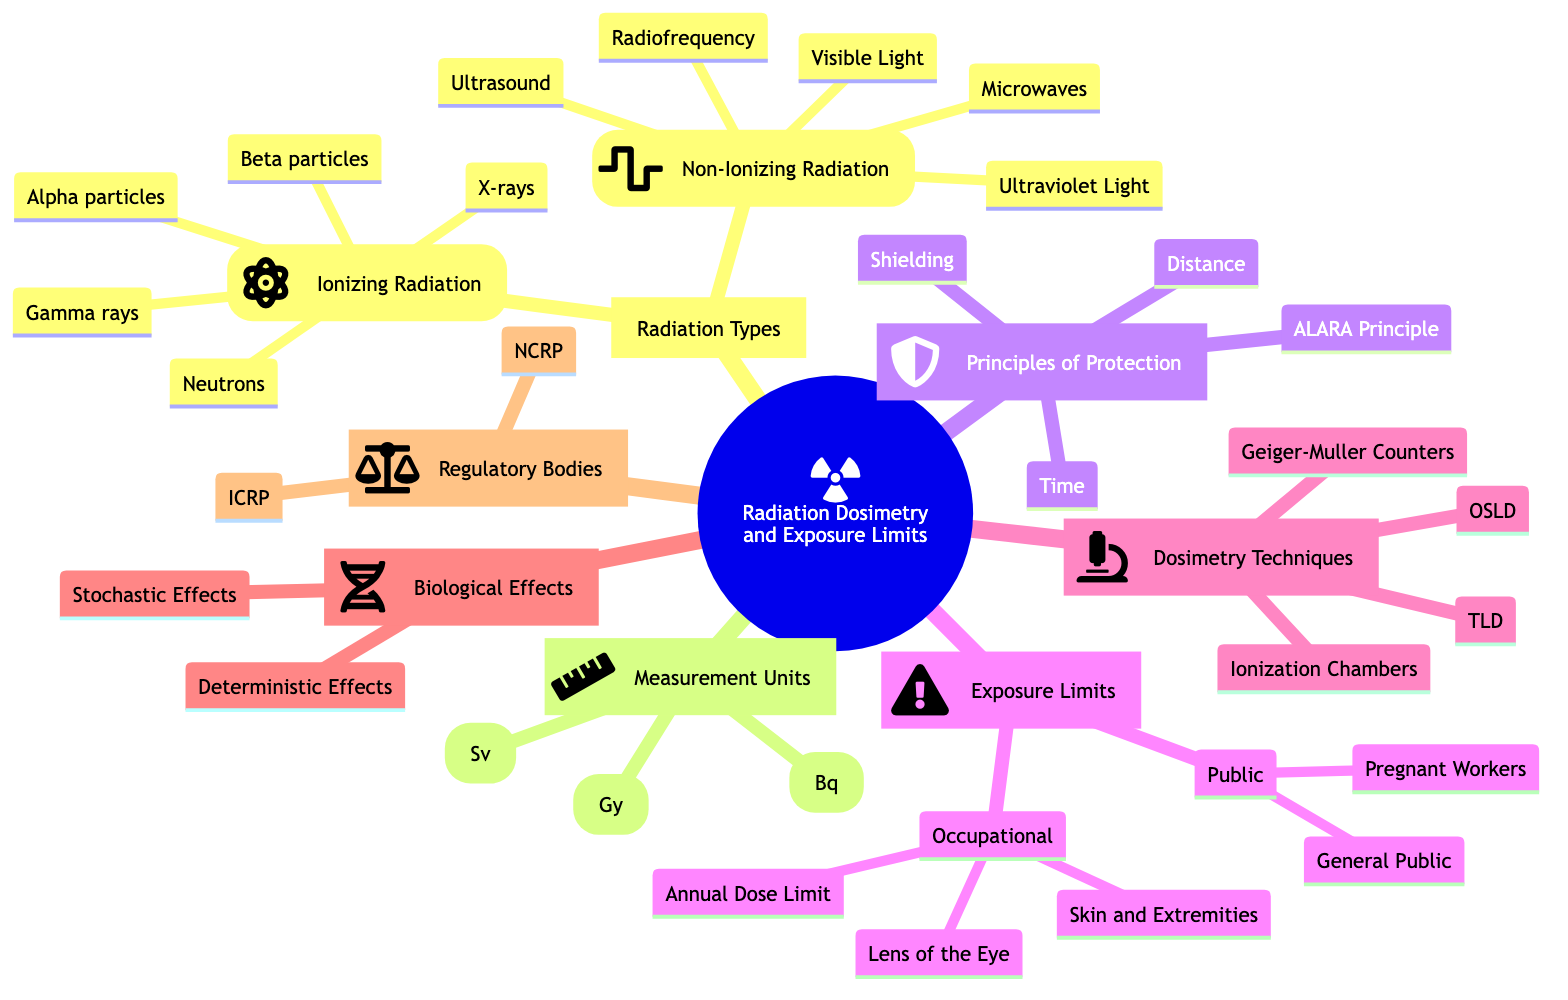What are the two main types of radiation listed? The mind map categorizes radiation into two main types under "Radiation Types": Ionizing Radiation and Non-Ionizing Radiation.
Answer: Ionizing Radiation, Non-Ionizing Radiation What is the annual dose limit for radiation workers? The map states that the annual dose limit for radiation workers falls under the "Occupational Limits" section, specifically mentioning '50 mSv per year'.
Answer: 50 mSv per year What does ALARA stand for? In the "Principles of Radiation Protection," ALARA is listed as the principle that stands for 'As Low As Reasonably Achievable'.
Answer: As Low As Reasonably Achievable Which unit measures the absorbed dose of radiation? In "Measurement Units," Gray (Gy) is defined as the unit that measures the 'absorbed dose of radiation'.
Answer: Gray (Gy) What kind of radiation does a Geiger-Muller Counter detect? The mind map indicates that Geiger-Muller Counters, found under "Radiation Dosimetry Techniques," specifically detect and measure 'ionizing radiation'.
Answer: Ionizing radiation What are the biological effects that correspond to increasing radiation dose severity? The mind map lists "Deterministic Effects" under "Biological Effects," which indicates that the severity of these effects increases with radiation dose.
Answer: Deterministic Effects Which regulatory body provides recommendations and guidelines? According to the "Regulatory Bodies" section of the map, the International Commission on Radiological Protection (ICRP) is responsible for providing recommendations and guidelines.
Answer: ICRP What is the effective dose unit used for biological impact? The map specifies that the unit Sievert (Sv) in the "Measurement Units" section is the effective dose used for 'biological impact'.
Answer: Sievert (Sv) How does the principle of distance relate to radiation exposure? In the "Principles of Radiation Protection," 'Distance' is listed as a principle aimed at minimizing exposure, indicating that maximizing distance from the radiation source reduces exposure risk.
Answer: Maximize distance from source 